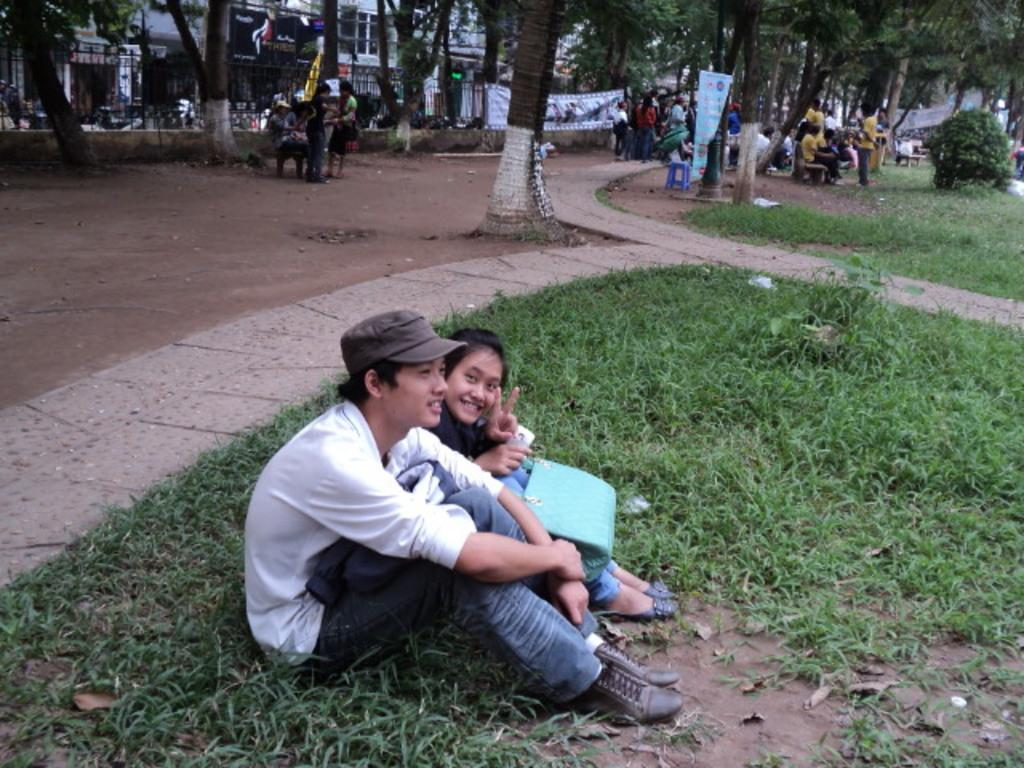How many people are the people in the image? There are people in the image. What type of seating is available in the image? There are benches in the image. What type of ground surface is visible in the image? There is grass in the image. What type of vegetation is present in the image? There are plants and trees in the image. What type of structures are visible in the image? There are buildings in the image. What type of decorations or signage is present in the image? There are banners in the image. How does the pollution affect the people in the image? There is no mention of pollution in the image, so it cannot be determined how it affects the people. Are the people in the image wearing masks? There is no mention of masks in the image, so it cannot be determined if the people are wearing them. 